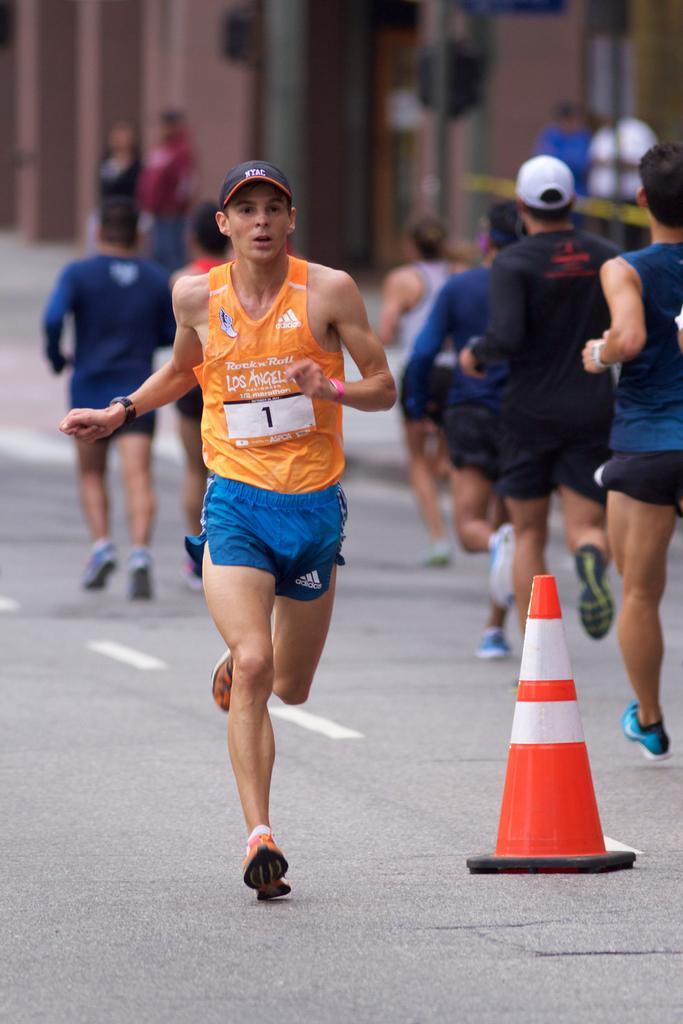How would you summarize this image in a sentence or two? In this image I can see group of people running, the person in front wearing orange and blue color dress, background I can see few poles and the building is in brown color. 